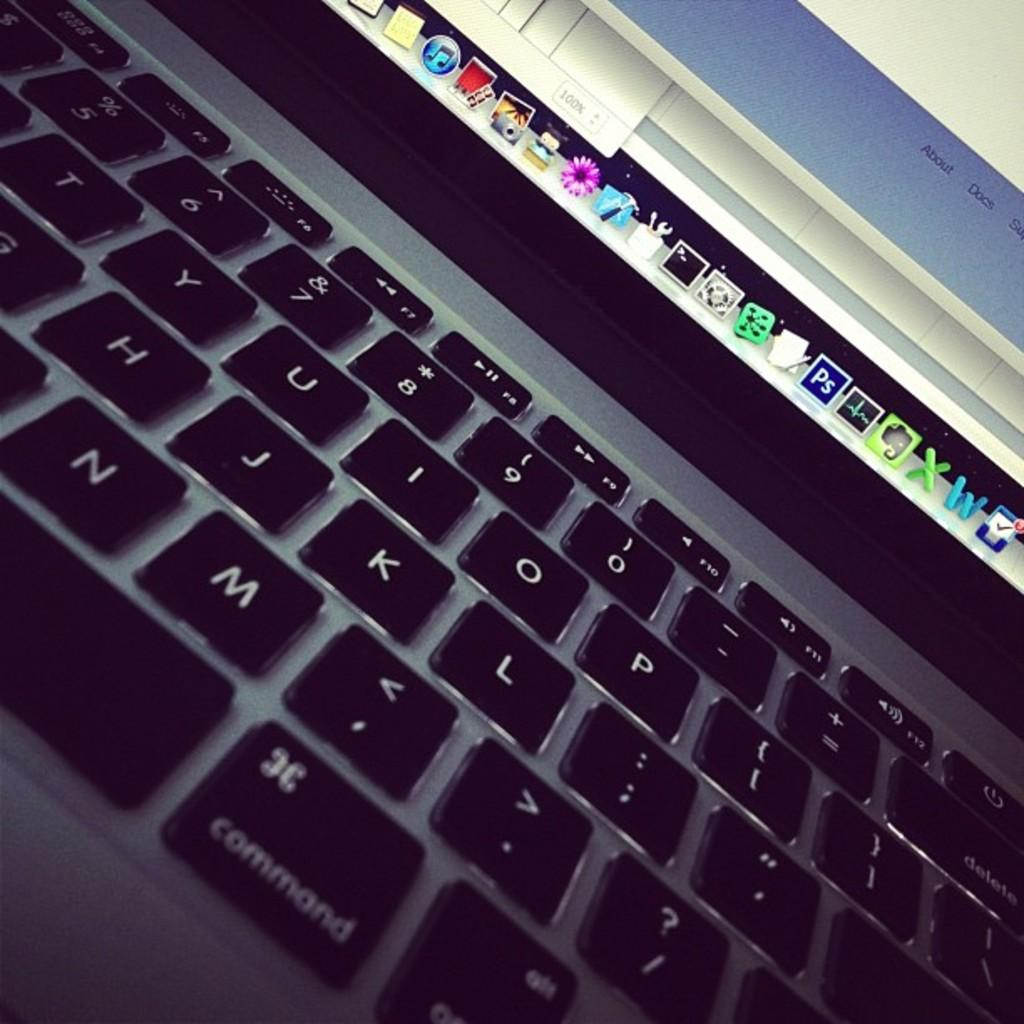<image>
Describe the image concisely. A keyboard of an open laptop with the icons on display. 